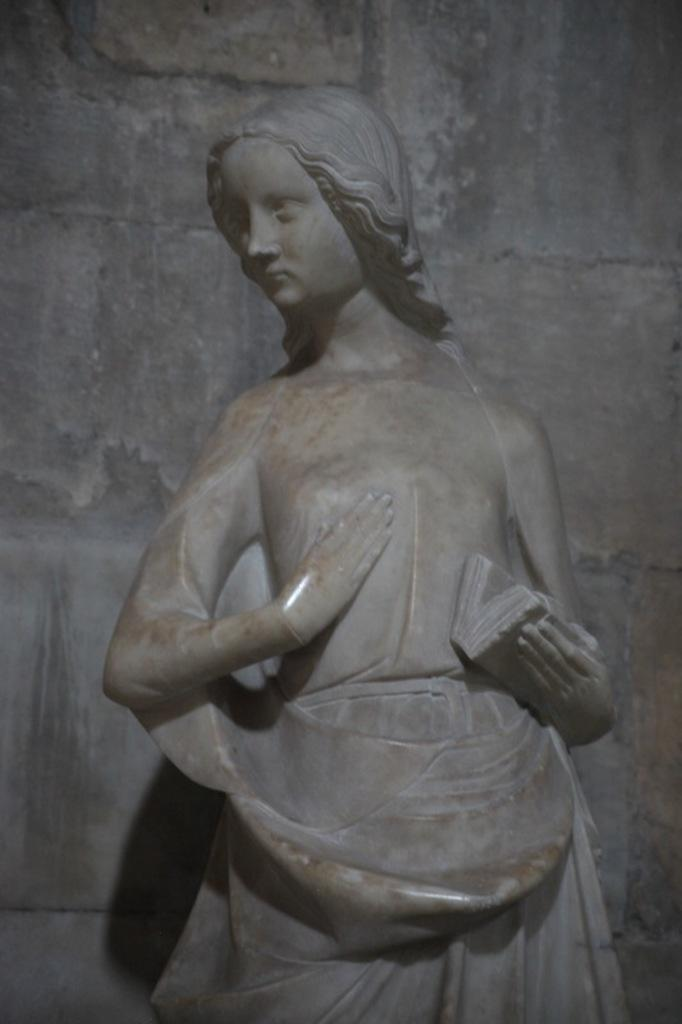What is the main subject in the center of the image? There is a statue in the center of the image. What can be seen in the background of the image? There is a wall in the background of the image. What type of ring is the statue wearing on its finger in the image? There is no ring visible on the statue's finger in the image. What health advice is the statue giving in the image? The statue is not giving any health advice in the image; it is a stationary object. 